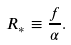<formula> <loc_0><loc_0><loc_500><loc_500>R _ { * } \equiv \frac { f } { \alpha } .</formula> 